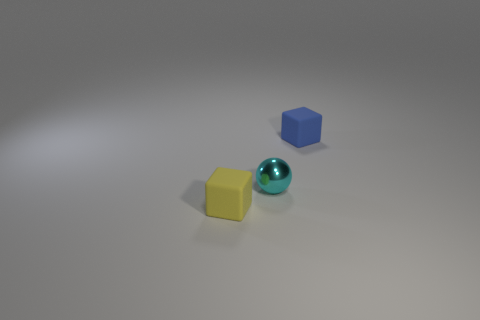Is there another yellow rubber cube that has the same size as the yellow rubber cube?
Your answer should be very brief. No. Does the cube right of the ball have the same material as the small yellow block?
Provide a short and direct response. Yes. Are there an equal number of tiny matte cubes on the left side of the small yellow thing and cyan things that are on the left side of the cyan shiny thing?
Offer a terse response. Yes. There is a object that is both behind the yellow matte object and in front of the tiny blue matte object; what is its shape?
Ensure brevity in your answer.  Sphere. How many small blue matte objects are on the left side of the tiny ball?
Your response must be concise. 0. How many other things are there of the same shape as the yellow rubber thing?
Your response must be concise. 1. Is the number of small cyan metal objects less than the number of tiny gray matte cylinders?
Provide a short and direct response. No. There is a thing that is left of the tiny blue thing and behind the small yellow cube; what size is it?
Your answer should be very brief. Small. There is a block behind the block that is on the left side of the rubber cube that is behind the cyan object; how big is it?
Ensure brevity in your answer.  Small. How big is the cyan ball?
Keep it short and to the point. Small. 